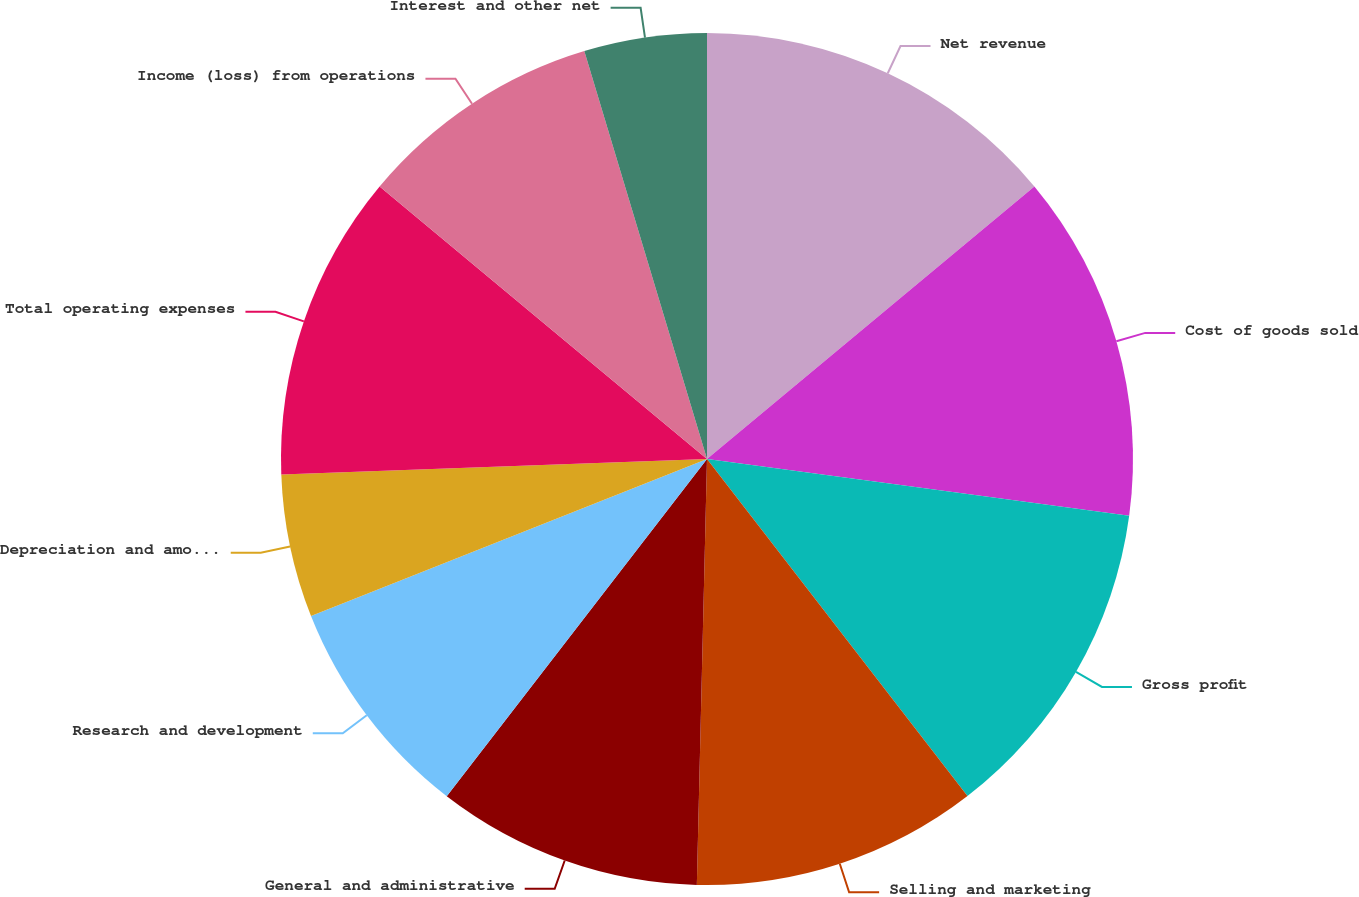<chart> <loc_0><loc_0><loc_500><loc_500><pie_chart><fcel>Net revenue<fcel>Cost of goods sold<fcel>Gross profit<fcel>Selling and marketing<fcel>General and administrative<fcel>Research and development<fcel>Depreciation and amortization<fcel>Total operating expenses<fcel>Income (loss) from operations<fcel>Interest and other net<nl><fcel>13.95%<fcel>13.18%<fcel>12.4%<fcel>10.85%<fcel>10.08%<fcel>8.53%<fcel>5.43%<fcel>11.63%<fcel>9.3%<fcel>4.65%<nl></chart> 